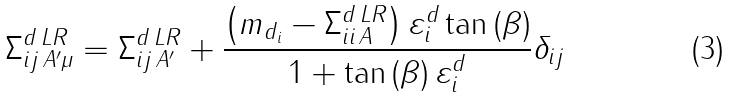<formula> <loc_0><loc_0><loc_500><loc_500>\Sigma _ { i j \, A ^ { \prime } \mu } ^ { d \, L R } = \Sigma _ { i j \, A ^ { \prime } } ^ { d \, L R } + \frac { { \left ( { m _ { d _ { i } } - \Sigma _ { i i \, A } ^ { d \, L R } } \right ) \varepsilon _ { i } ^ { d } \tan \left ( \beta \right ) } } { 1 + \tan \left ( \beta \right ) \varepsilon _ { i } ^ { d } } \delta _ { i j }</formula> 